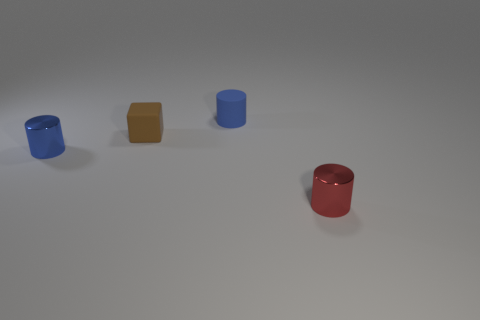Is there anything else that is the same color as the matte cylinder?
Your response must be concise. Yes. There is a tiny red shiny thing; is it the same shape as the object that is behind the brown cube?
Provide a succinct answer. Yes. There is a thing that is in front of the cylinder that is on the left side of the tiny blue thing that is behind the small brown matte thing; what color is it?
Your answer should be compact. Red. Is there anything else that is made of the same material as the small brown thing?
Keep it short and to the point. Yes. Does the tiny blue object that is on the left side of the small brown cube have the same shape as the red thing?
Your response must be concise. Yes. What is the brown object made of?
Provide a short and direct response. Rubber. There is a blue thing to the right of the cylinder that is to the left of the small blue object to the right of the brown cube; what shape is it?
Your response must be concise. Cylinder. How many other objects are the same shape as the small red metal object?
Provide a short and direct response. 2. There is a rubber cylinder; is it the same color as the thing left of the tiny brown rubber object?
Offer a terse response. Yes. How many small shiny objects are there?
Keep it short and to the point. 2. 